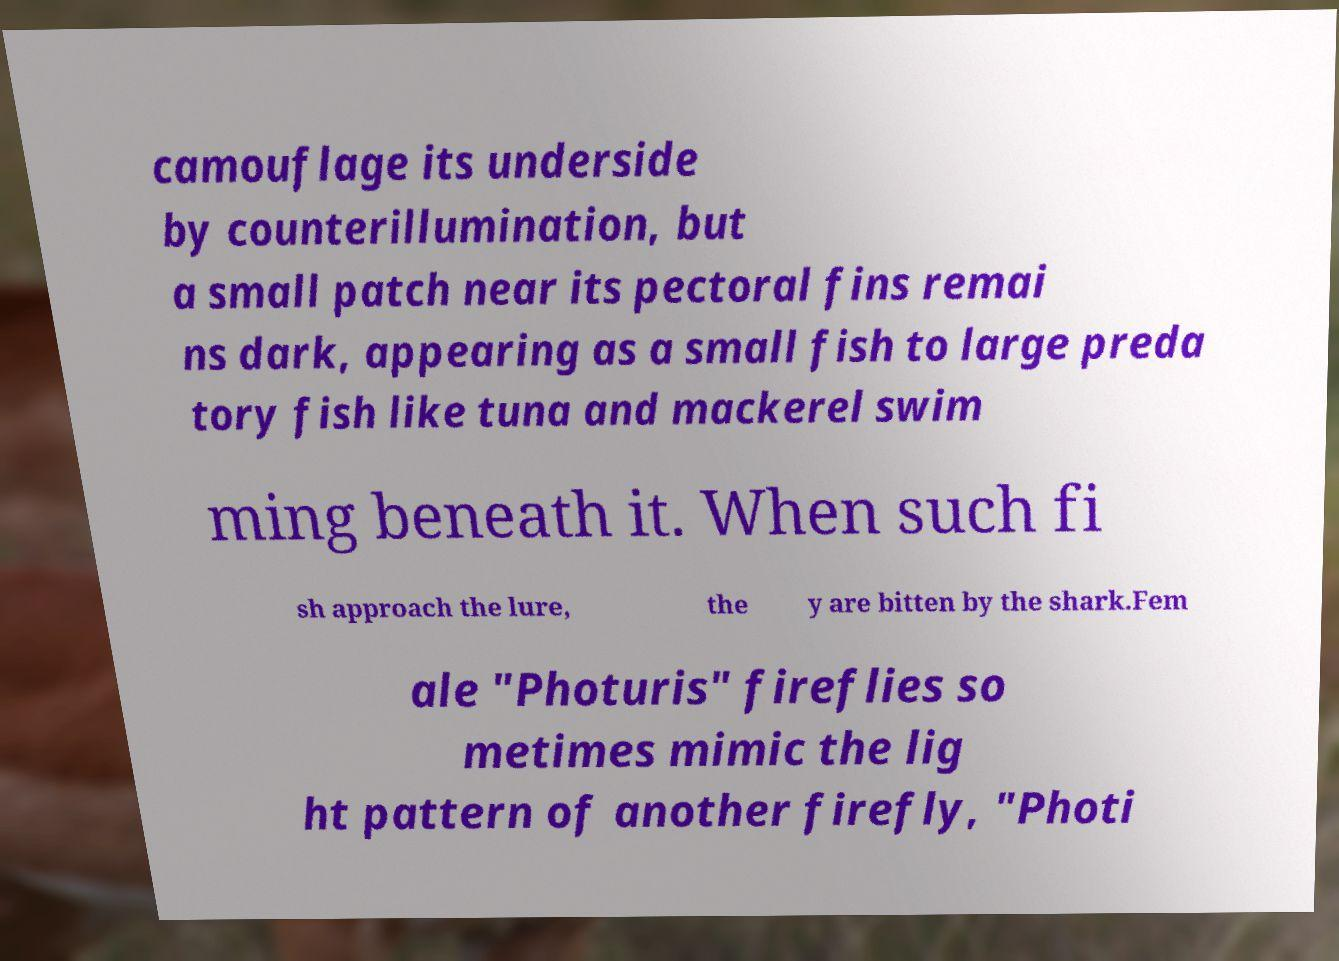Could you assist in decoding the text presented in this image and type it out clearly? camouflage its underside by counterillumination, but a small patch near its pectoral fins remai ns dark, appearing as a small fish to large preda tory fish like tuna and mackerel swim ming beneath it. When such fi sh approach the lure, the y are bitten by the shark.Fem ale "Photuris" fireflies so metimes mimic the lig ht pattern of another firefly, "Photi 